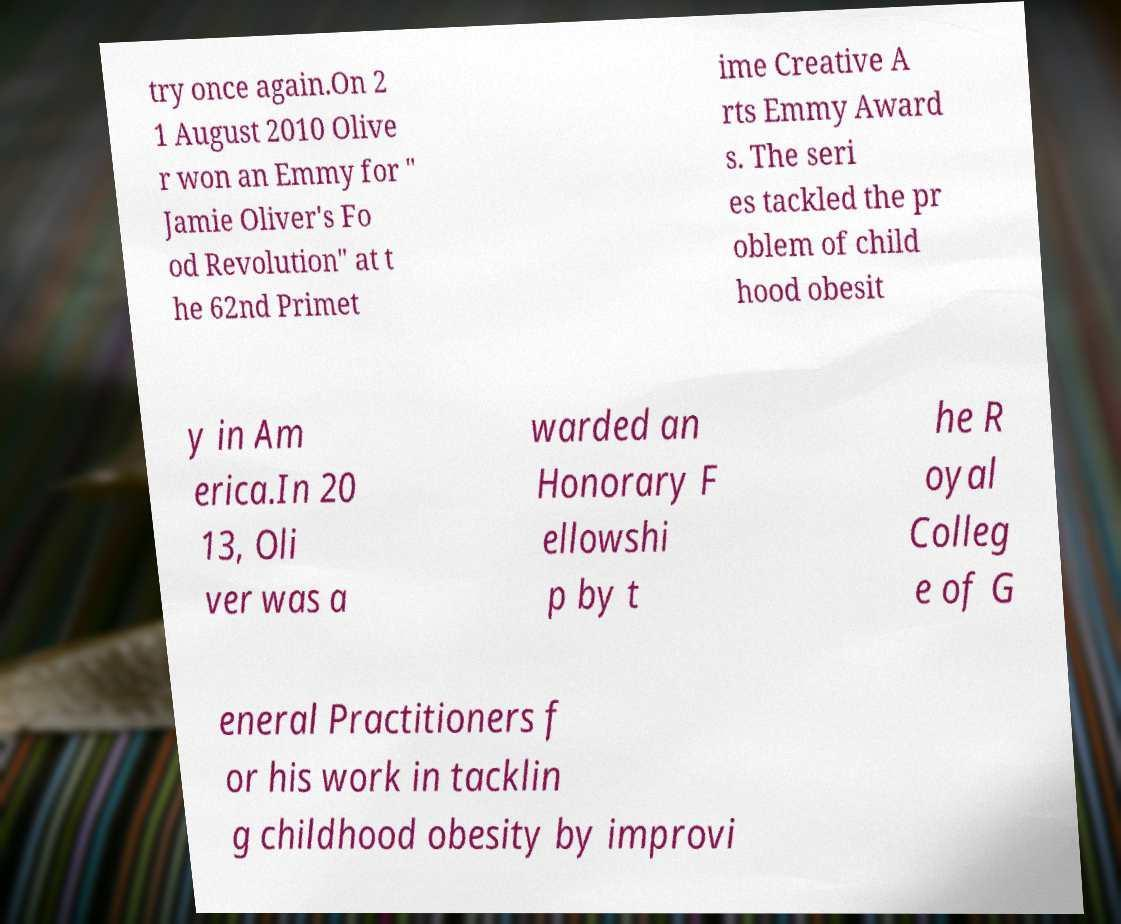Please read and relay the text visible in this image. What does it say? try once again.On 2 1 August 2010 Olive r won an Emmy for " Jamie Oliver's Fo od Revolution" at t he 62nd Primet ime Creative A rts Emmy Award s. The seri es tackled the pr oblem of child hood obesit y in Am erica.In 20 13, Oli ver was a warded an Honorary F ellowshi p by t he R oyal Colleg e of G eneral Practitioners f or his work in tacklin g childhood obesity by improvi 